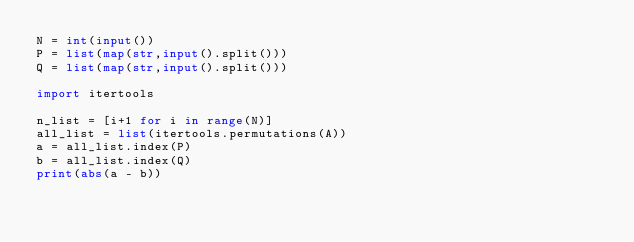Convert code to text. <code><loc_0><loc_0><loc_500><loc_500><_Python_>N = int(input())
P = list(map(str,input().split()))
Q = list(map(str,input().split()))

import itertools
 
n_list = [i+1 for i in range(N)]
all_list = list(itertools.permutations(A))
a = all_list.index(P)
b = all_list.index(Q)
print(abs(a - b))
</code> 